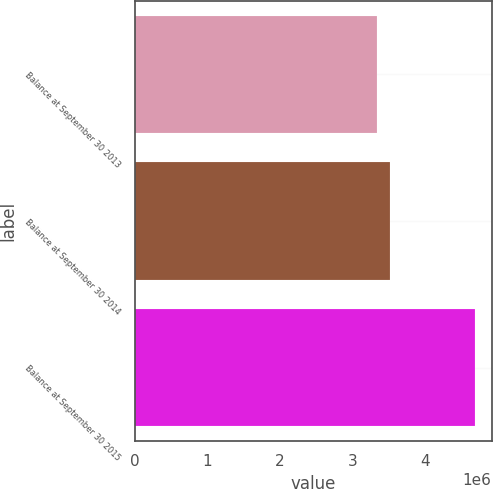Convert chart to OTSL. <chart><loc_0><loc_0><loc_500><loc_500><bar_chart><fcel>Balance at September 30 2013<fcel>Balance at September 30 2014<fcel>Balance at September 30 2015<nl><fcel>3.34391e+06<fcel>3.52508e+06<fcel>4.68622e+06<nl></chart> 